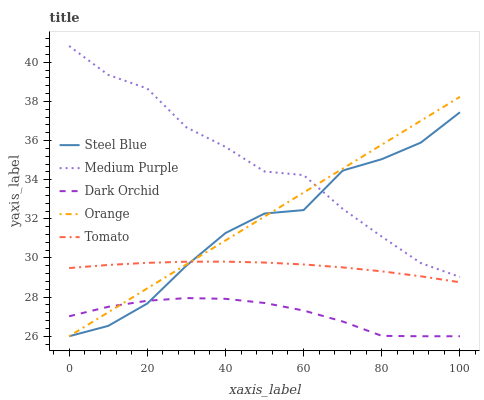Does Dark Orchid have the minimum area under the curve?
Answer yes or no. Yes. Does Medium Purple have the maximum area under the curve?
Answer yes or no. Yes. Does Orange have the minimum area under the curve?
Answer yes or no. No. Does Orange have the maximum area under the curve?
Answer yes or no. No. Is Orange the smoothest?
Answer yes or no. Yes. Is Steel Blue the roughest?
Answer yes or no. Yes. Is Tomato the smoothest?
Answer yes or no. No. Is Tomato the roughest?
Answer yes or no. No. Does Orange have the lowest value?
Answer yes or no. Yes. Does Tomato have the lowest value?
Answer yes or no. No. Does Medium Purple have the highest value?
Answer yes or no. Yes. Does Orange have the highest value?
Answer yes or no. No. Is Tomato less than Medium Purple?
Answer yes or no. Yes. Is Tomato greater than Dark Orchid?
Answer yes or no. Yes. Does Medium Purple intersect Steel Blue?
Answer yes or no. Yes. Is Medium Purple less than Steel Blue?
Answer yes or no. No. Is Medium Purple greater than Steel Blue?
Answer yes or no. No. Does Tomato intersect Medium Purple?
Answer yes or no. No. 